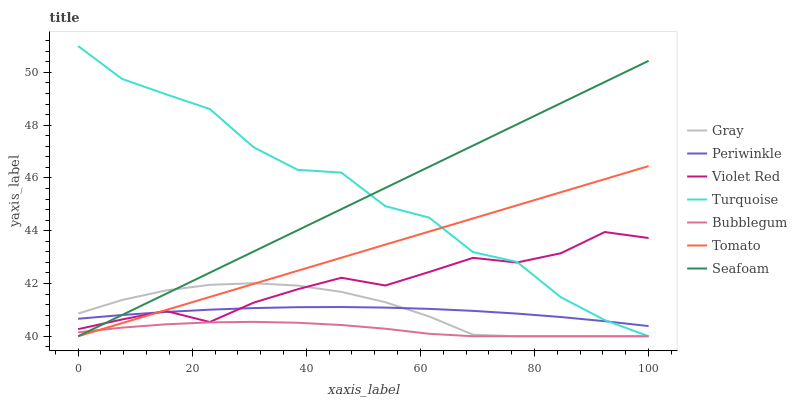Does Bubblegum have the minimum area under the curve?
Answer yes or no. Yes. Does Turquoise have the maximum area under the curve?
Answer yes or no. Yes. Does Gray have the minimum area under the curve?
Answer yes or no. No. Does Gray have the maximum area under the curve?
Answer yes or no. No. Is Tomato the smoothest?
Answer yes or no. Yes. Is Turquoise the roughest?
Answer yes or no. Yes. Is Gray the smoothest?
Answer yes or no. No. Is Gray the roughest?
Answer yes or no. No. Does Tomato have the lowest value?
Answer yes or no. Yes. Does Violet Red have the lowest value?
Answer yes or no. No. Does Turquoise have the highest value?
Answer yes or no. Yes. Does Gray have the highest value?
Answer yes or no. No. Is Bubblegum less than Periwinkle?
Answer yes or no. Yes. Is Periwinkle greater than Bubblegum?
Answer yes or no. Yes. Does Gray intersect Violet Red?
Answer yes or no. Yes. Is Gray less than Violet Red?
Answer yes or no. No. Is Gray greater than Violet Red?
Answer yes or no. No. Does Bubblegum intersect Periwinkle?
Answer yes or no. No. 